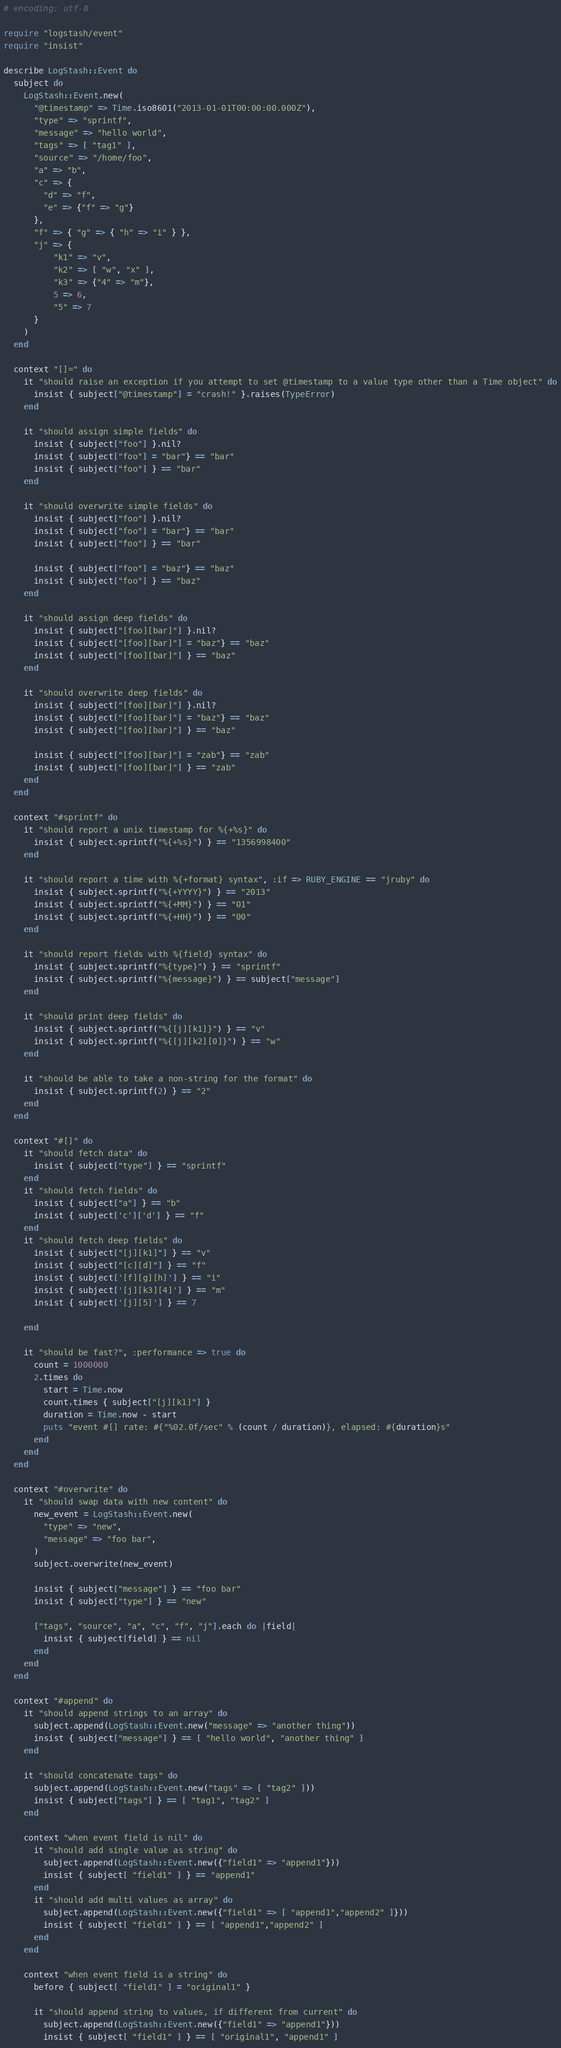Convert code to text. <code><loc_0><loc_0><loc_500><loc_500><_Ruby_># encoding: utf-8

require "logstash/event"
require "insist"

describe LogStash::Event do
  subject do
    LogStash::Event.new(
      "@timestamp" => Time.iso8601("2013-01-01T00:00:00.000Z"),
      "type" => "sprintf",
      "message" => "hello world",
      "tags" => [ "tag1" ],
      "source" => "/home/foo",
      "a" => "b",
      "c" => {
        "d" => "f",
        "e" => {"f" => "g"}
      },
      "f" => { "g" => { "h" => "i" } },
      "j" => {
          "k1" => "v",
          "k2" => [ "w", "x" ],
          "k3" => {"4" => "m"},
          5 => 6,
          "5" => 7
      }
    )
  end

  context "[]=" do
    it "should raise an exception if you attempt to set @timestamp to a value type other than a Time object" do
      insist { subject["@timestamp"] = "crash!" }.raises(TypeError)
    end

    it "should assign simple fields" do
      insist { subject["foo"] }.nil?
      insist { subject["foo"] = "bar"} == "bar"
      insist { subject["foo"] } == "bar"
    end

    it "should overwrite simple fields" do
      insist { subject["foo"] }.nil?
      insist { subject["foo"] = "bar"} == "bar"
      insist { subject["foo"] } == "bar"

      insist { subject["foo"] = "baz"} == "baz"
      insist { subject["foo"] } == "baz"
    end

    it "should assign deep fields" do
      insist { subject["[foo][bar]"] }.nil?
      insist { subject["[foo][bar]"] = "baz"} == "baz"
      insist { subject["[foo][bar]"] } == "baz"
    end

    it "should overwrite deep fields" do
      insist { subject["[foo][bar]"] }.nil?
      insist { subject["[foo][bar]"] = "baz"} == "baz"
      insist { subject["[foo][bar]"] } == "baz"

      insist { subject["[foo][bar]"] = "zab"} == "zab"
      insist { subject["[foo][bar]"] } == "zab"
    end
  end

  context "#sprintf" do
    it "should report a unix timestamp for %{+%s}" do
      insist { subject.sprintf("%{+%s}") } == "1356998400"
    end

    it "should report a time with %{+format} syntax", :if => RUBY_ENGINE == "jruby" do
      insist { subject.sprintf("%{+YYYY}") } == "2013"
      insist { subject.sprintf("%{+MM}") } == "01"
      insist { subject.sprintf("%{+HH}") } == "00"
    end

    it "should report fields with %{field} syntax" do
      insist { subject.sprintf("%{type}") } == "sprintf"
      insist { subject.sprintf("%{message}") } == subject["message"]
    end

    it "should print deep fields" do
      insist { subject.sprintf("%{[j][k1]}") } == "v"
      insist { subject.sprintf("%{[j][k2][0]}") } == "w"
    end

    it "should be able to take a non-string for the format" do
      insist { subject.sprintf(2) } == "2"
    end
  end

  context "#[]" do
    it "should fetch data" do
      insist { subject["type"] } == "sprintf"
    end
    it "should fetch fields" do
      insist { subject["a"] } == "b"
      insist { subject['c']['d'] } == "f"
    end
    it "should fetch deep fields" do
      insist { subject["[j][k1]"] } == "v"
      insist { subject["[c][d]"] } == "f"
      insist { subject['[f][g][h]'] } == "i"
      insist { subject['[j][k3][4]'] } == "m"
      insist { subject['[j][5]'] } == 7

    end

    it "should be fast?", :performance => true do
      count = 1000000
      2.times do
        start = Time.now
        count.times { subject["[j][k1]"] }
        duration = Time.now - start
        puts "event #[] rate: #{"%02.0f/sec" % (count / duration)}, elapsed: #{duration}s"
      end
    end
  end

  context "#overwrite" do
    it "should swap data with new content" do
      new_event = LogStash::Event.new(
        "type" => "new",
        "message" => "foo bar",
      )
      subject.overwrite(new_event)

      insist { subject["message"] } == "foo bar"
      insist { subject["type"] } == "new"

      ["tags", "source", "a", "c", "f", "j"].each do |field|
        insist { subject[field] } == nil
      end
    end
  end

  context "#append" do
    it "should append strings to an array" do
      subject.append(LogStash::Event.new("message" => "another thing"))
      insist { subject["message"] } == [ "hello world", "another thing" ]
    end

    it "should concatenate tags" do
      subject.append(LogStash::Event.new("tags" => [ "tag2" ]))
      insist { subject["tags"] } == [ "tag1", "tag2" ]
    end

    context "when event field is nil" do
      it "should add single value as string" do
        subject.append(LogStash::Event.new({"field1" => "append1"}))
        insist { subject[ "field1" ] } == "append1"
      end
      it "should add multi values as array" do
        subject.append(LogStash::Event.new({"field1" => [ "append1","append2" ]}))
        insist { subject[ "field1" ] } == [ "append1","append2" ]
      end
    end

    context "when event field is a string" do
      before { subject[ "field1" ] = "original1" }

      it "should append string to values, if different from current" do
        subject.append(LogStash::Event.new({"field1" => "append1"}))
        insist { subject[ "field1" ] } == [ "original1", "append1" ]</code> 